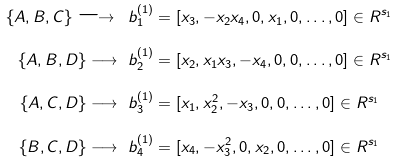<formula> <loc_0><loc_0><loc_500><loc_500>\{ A , B , C \} \longrightarrow \ b _ { 1 } ^ { ( 1 ) } & = [ x _ { 3 } , - x _ { 2 } x _ { 4 } , 0 , x _ { 1 } , 0 , \dots , 0 ] \in R ^ { s _ { 1 } } \\ \{ A , B , D \} \longrightarrow \ b _ { 2 } ^ { ( 1 ) } & = [ x _ { 2 } , x _ { 1 } x _ { 3 } , - x _ { 4 } , 0 , 0 , \dots , 0 ] \in R ^ { s _ { 1 } } \\ \{ A , C , D \} \longrightarrow \ b _ { 3 } ^ { ( 1 ) } & = [ x _ { 1 } , x _ { 2 } ^ { 2 } , - x _ { 3 } , 0 , 0 , \dots , 0 ] \in R ^ { s _ { 1 } } \\ \{ B , C , D \} \longrightarrow \ b _ { 4 } ^ { ( 1 ) } & = [ x _ { 4 } , - x _ { 3 } ^ { 2 } , 0 , x _ { 2 } , 0 , \dots , 0 ] \in R ^ { s _ { 1 } }</formula> 